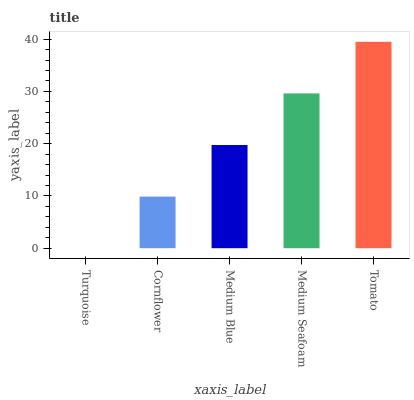Is Turquoise the minimum?
Answer yes or no. Yes. Is Tomato the maximum?
Answer yes or no. Yes. Is Cornflower the minimum?
Answer yes or no. No. Is Cornflower the maximum?
Answer yes or no. No. Is Cornflower greater than Turquoise?
Answer yes or no. Yes. Is Turquoise less than Cornflower?
Answer yes or no. Yes. Is Turquoise greater than Cornflower?
Answer yes or no. No. Is Cornflower less than Turquoise?
Answer yes or no. No. Is Medium Blue the high median?
Answer yes or no. Yes. Is Medium Blue the low median?
Answer yes or no. Yes. Is Turquoise the high median?
Answer yes or no. No. Is Tomato the low median?
Answer yes or no. No. 